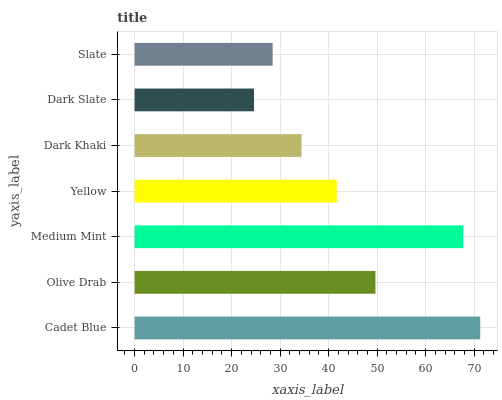Is Dark Slate the minimum?
Answer yes or no. Yes. Is Cadet Blue the maximum?
Answer yes or no. Yes. Is Olive Drab the minimum?
Answer yes or no. No. Is Olive Drab the maximum?
Answer yes or no. No. Is Cadet Blue greater than Olive Drab?
Answer yes or no. Yes. Is Olive Drab less than Cadet Blue?
Answer yes or no. Yes. Is Olive Drab greater than Cadet Blue?
Answer yes or no. No. Is Cadet Blue less than Olive Drab?
Answer yes or no. No. Is Yellow the high median?
Answer yes or no. Yes. Is Yellow the low median?
Answer yes or no. Yes. Is Dark Khaki the high median?
Answer yes or no. No. Is Olive Drab the low median?
Answer yes or no. No. 